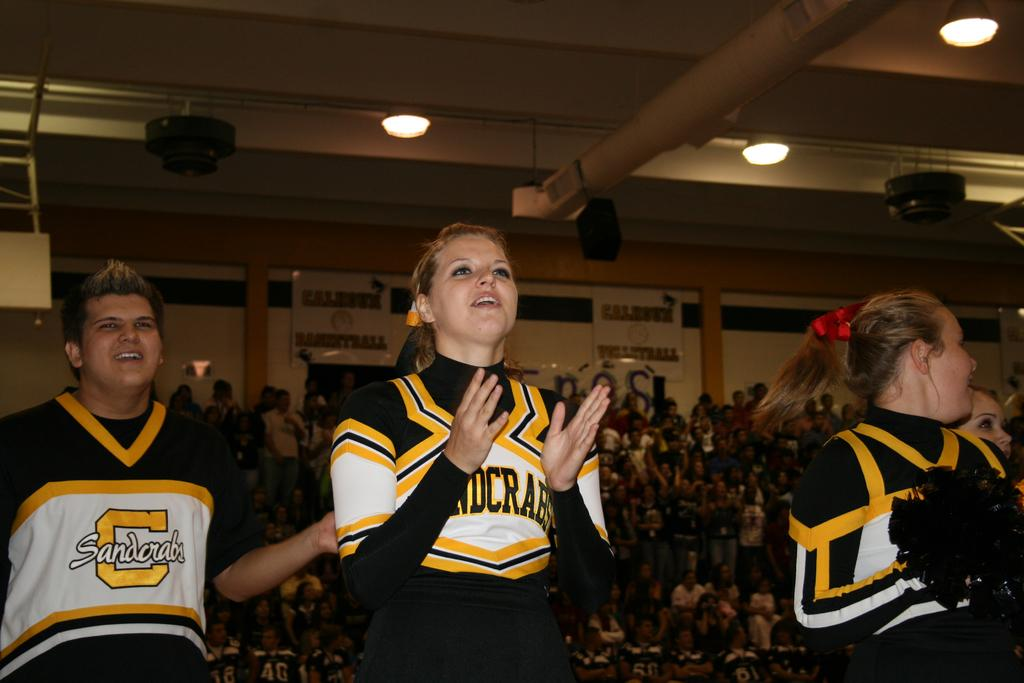<image>
Create a compact narrative representing the image presented. Cheerleaders are clapping at a game with jerseys that say Sandcrabs. 